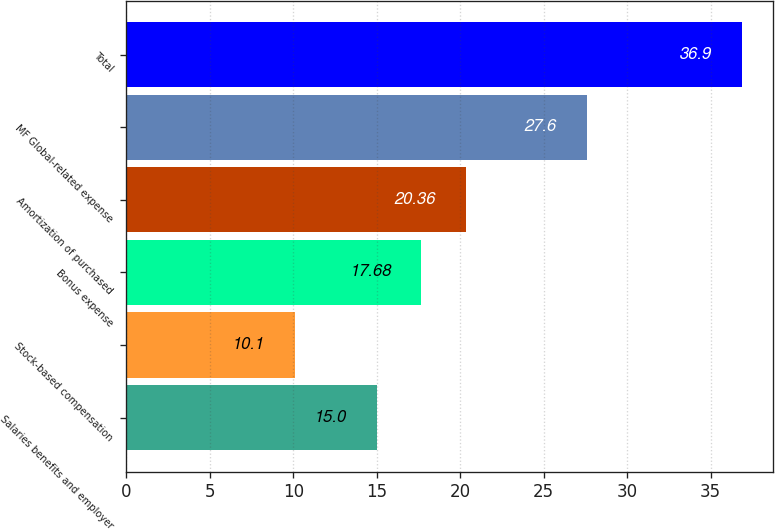Convert chart to OTSL. <chart><loc_0><loc_0><loc_500><loc_500><bar_chart><fcel>Salaries benefits and employer<fcel>Stock-based compensation<fcel>Bonus expense<fcel>Amortization of purchased<fcel>MF Global-related expense<fcel>Total<nl><fcel>15<fcel>10.1<fcel>17.68<fcel>20.36<fcel>27.6<fcel>36.9<nl></chart> 